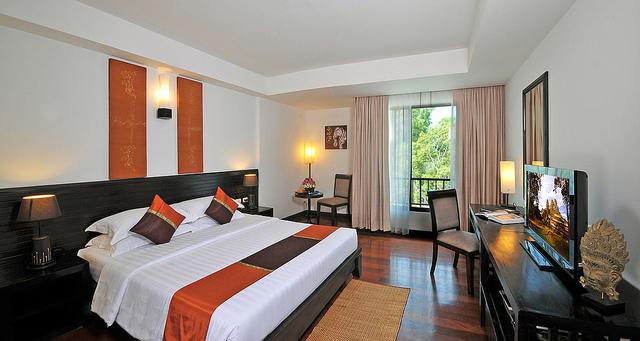What is placed on top of the black table?
Keep it brief. Tv. How many beds?
Write a very short answer. 1. How many pillows are there?
Write a very short answer. 6. How many lamps are in this room?
Concise answer only. 4. What kind of room is this?
Short answer required. Bedroom. 